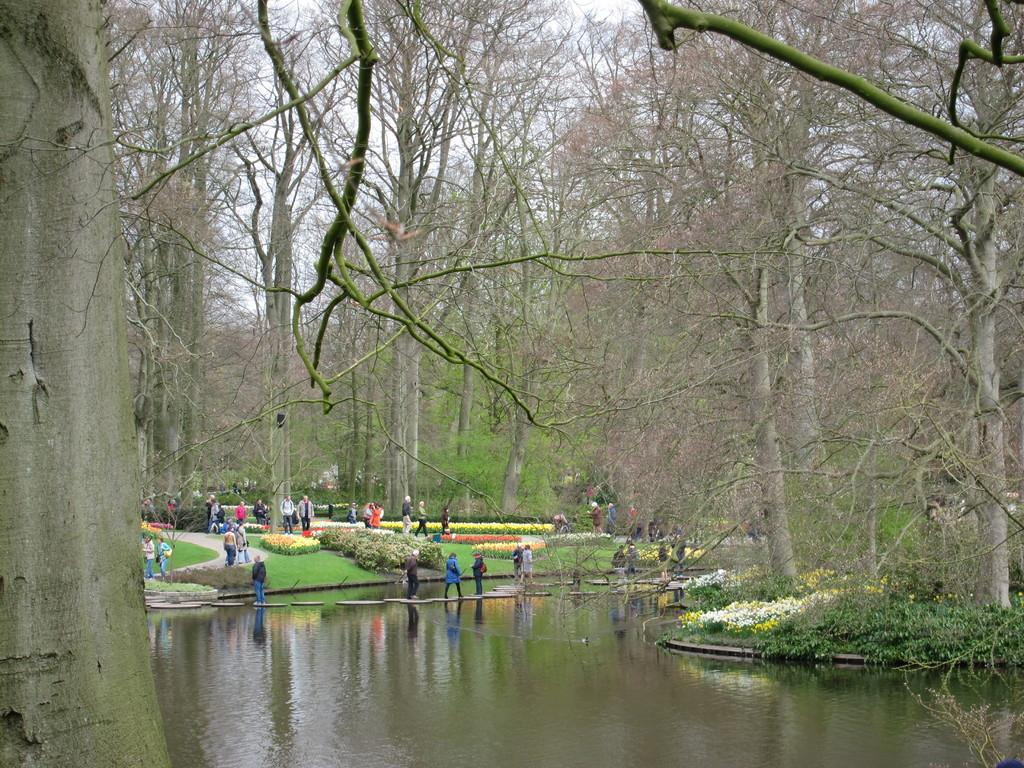What is the main feature of the image? The main feature of the image is a water surface. What can be seen around the water surface? The water surface is surrounded by a beautiful park. What is the atmosphere like in the park? There are many people in the park, which suggests a lively and social environment. What type of vegetation is present in the park? There are tall trees in the park. What type of brush is being used by the person in the image? There is no person using a brush in the image; it features a water surface surrounded by a park. What type of test is being conducted in the image? There is no test being conducted in the image; it features a water surface surrounded by a park. 